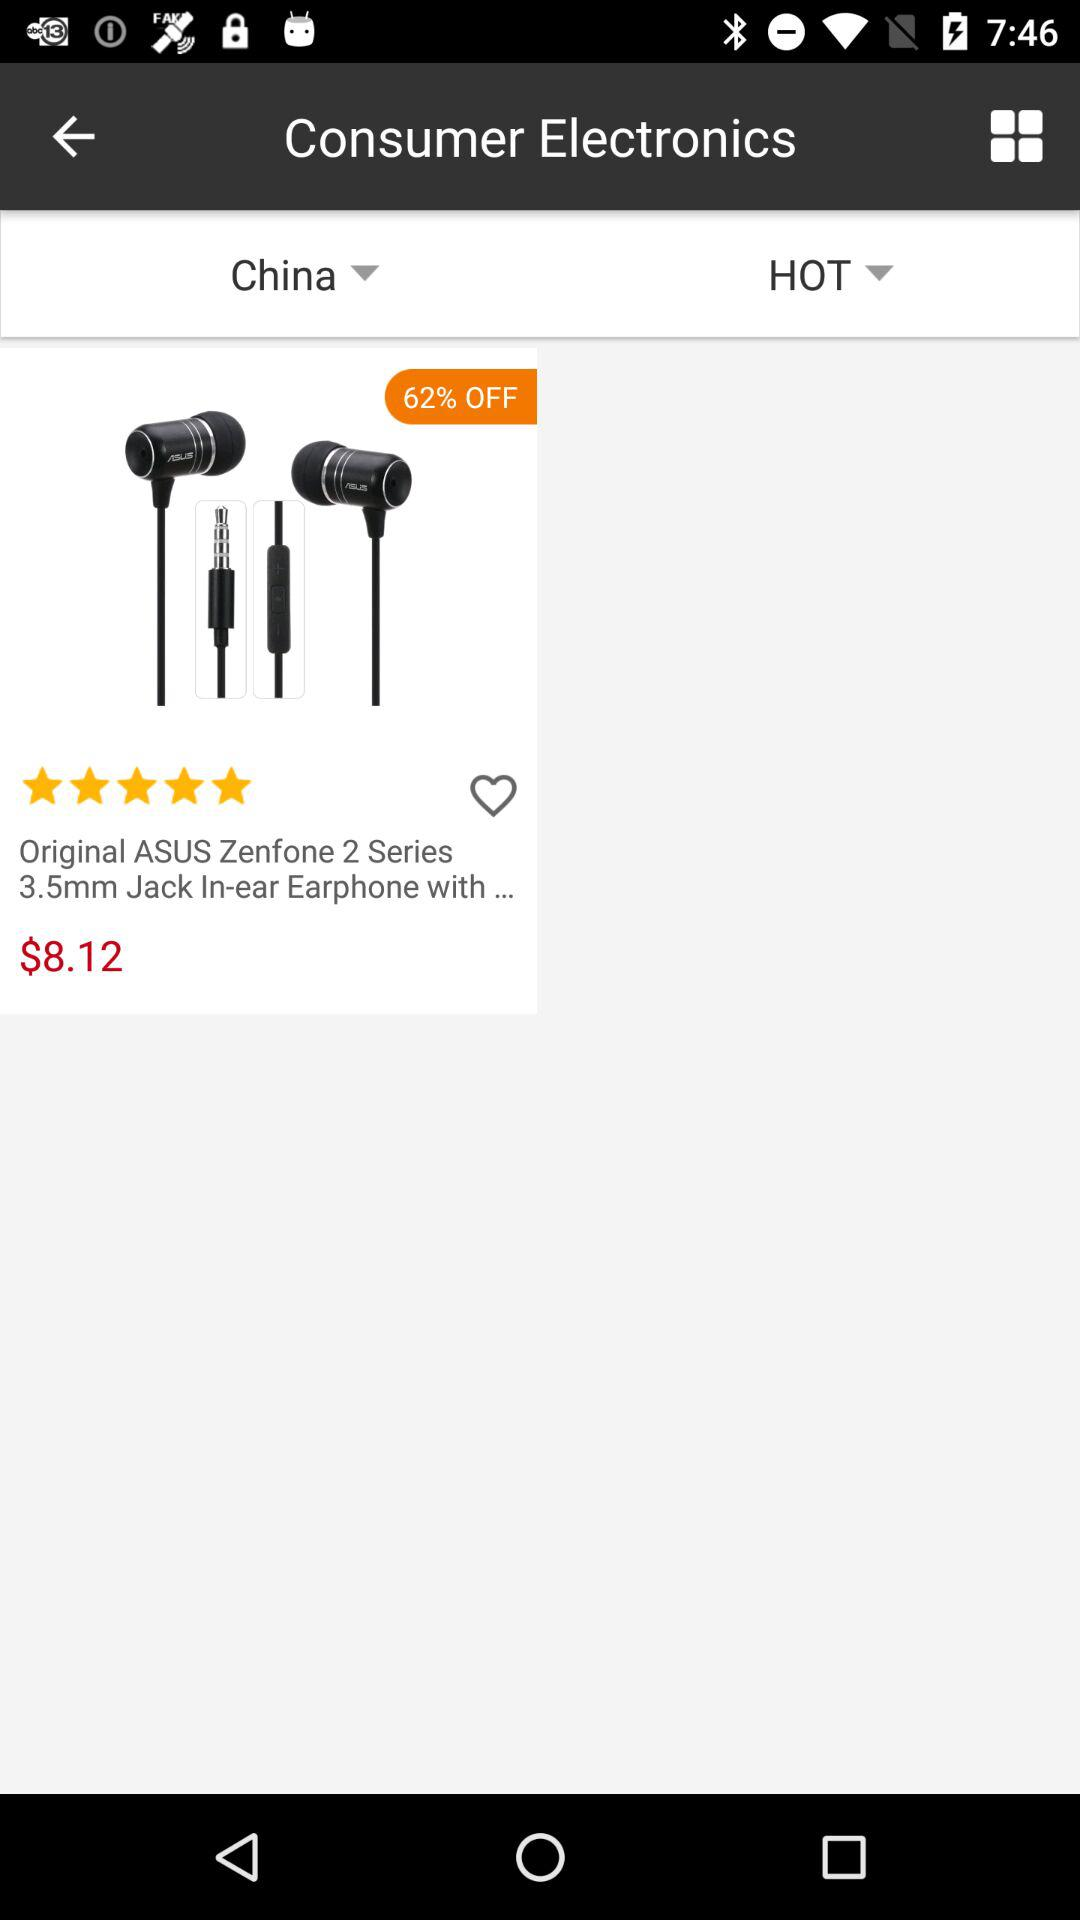What is the brand of the earphones? The brand of the earphones is "ASUS". 